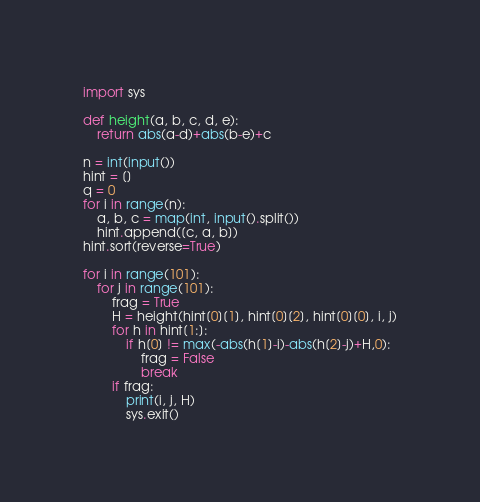<code> <loc_0><loc_0><loc_500><loc_500><_Python_>import sys

def height(a, b, c, d, e):
    return abs(a-d)+abs(b-e)+c

n = int(input())
hint = []
q = 0
for i in range(n):
    a, b, c = map(int, input().split())
    hint.append([c, a, b])
hint.sort(reverse=True)

for i in range(101):
    for j in range(101):
        frag = True
        H = height(hint[0][1], hint[0][2], hint[0][0], i, j)
        for h in hint[1:]:
            if h[0] != max(-abs(h[1]-i)-abs(h[2]-j)+H,0):
                frag = False
                break
        if frag:
            print(i, j, H)
            sys.exit()</code> 